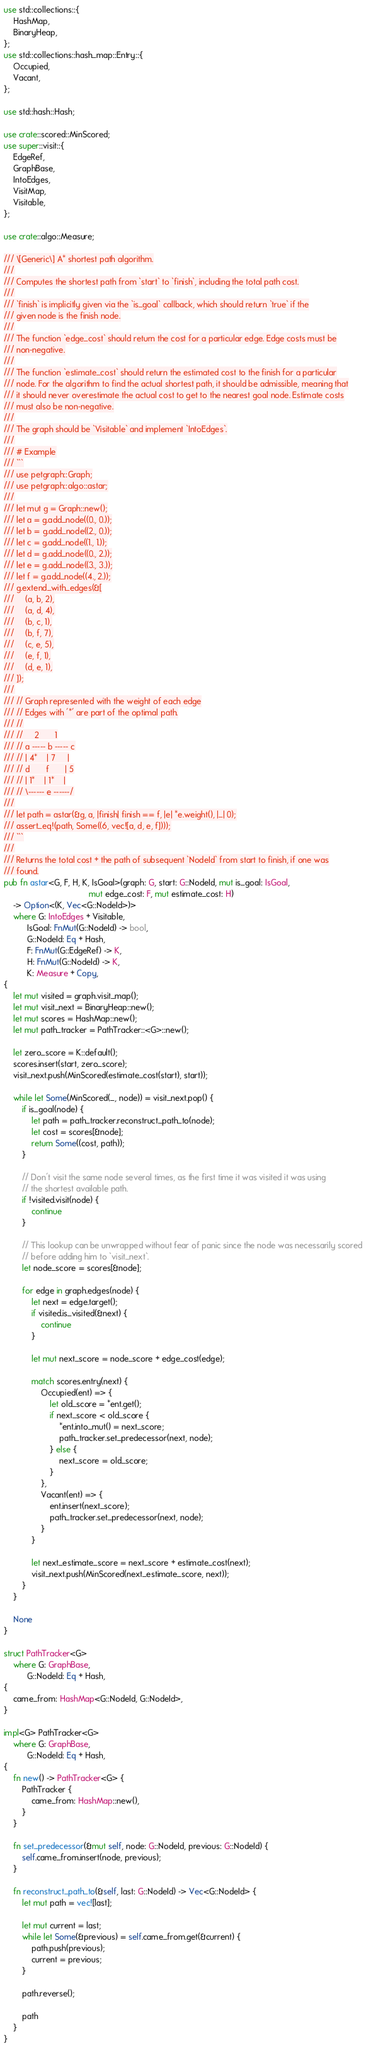<code> <loc_0><loc_0><loc_500><loc_500><_Rust_>use std::collections::{
    HashMap,
    BinaryHeap,
};
use std::collections::hash_map::Entry::{
    Occupied,
    Vacant,
};

use std::hash::Hash;

use crate::scored::MinScored;
use super::visit::{
    EdgeRef,
    GraphBase,
    IntoEdges,
    VisitMap,
    Visitable,
};

use crate::algo::Measure;

/// \[Generic\] A* shortest path algorithm.
///
/// Computes the shortest path from `start` to `finish`, including the total path cost.
///
/// `finish` is implicitly given via the `is_goal` callback, which should return `true` if the
/// given node is the finish node.
///
/// The function `edge_cost` should return the cost for a particular edge. Edge costs must be
/// non-negative.
///
/// The function `estimate_cost` should return the estimated cost to the finish for a particular
/// node. For the algorithm to find the actual shortest path, it should be admissible, meaning that
/// it should never overestimate the actual cost to get to the nearest goal node. Estimate costs
/// must also be non-negative.
///
/// The graph should be `Visitable` and implement `IntoEdges`.
///
/// # Example
/// ```
/// use petgraph::Graph;
/// use petgraph::algo::astar;
///
/// let mut g = Graph::new();
/// let a = g.add_node((0., 0.));
/// let b = g.add_node((2., 0.));
/// let c = g.add_node((1., 1.));
/// let d = g.add_node((0., 2.));
/// let e = g.add_node((3., 3.));
/// let f = g.add_node((4., 2.));
/// g.extend_with_edges(&[
///     (a, b, 2),
///     (a, d, 4),
///     (b, c, 1),
///     (b, f, 7),
///     (c, e, 5),
///     (e, f, 1),
///     (d, e, 1),
/// ]);
///
/// // Graph represented with the weight of each edge
/// // Edges with '*' are part of the optimal path.
/// //
/// //     2       1
/// // a ----- b ----- c
/// // | 4*    | 7     |
/// // d       f       | 5
/// // | 1*    | 1*    |
/// // \------ e ------/
///
/// let path = astar(&g, a, |finish| finish == f, |e| *e.weight(), |_| 0);
/// assert_eq!(path, Some((6, vec![a, d, e, f])));
/// ```
///
/// Returns the total cost + the path of subsequent `NodeId` from start to finish, if one was
/// found.
pub fn astar<G, F, H, K, IsGoal>(graph: G, start: G::NodeId, mut is_goal: IsGoal,
                                     mut edge_cost: F, mut estimate_cost: H)
    -> Option<(K, Vec<G::NodeId>)>
    where G: IntoEdges + Visitable,
          IsGoal: FnMut(G::NodeId) -> bool,
          G::NodeId: Eq + Hash,
          F: FnMut(G::EdgeRef) -> K,
          H: FnMut(G::NodeId) -> K,
          K: Measure + Copy,
{
    let mut visited = graph.visit_map();
    let mut visit_next = BinaryHeap::new();
    let mut scores = HashMap::new();
    let mut path_tracker = PathTracker::<G>::new();

    let zero_score = K::default();
    scores.insert(start, zero_score);
    visit_next.push(MinScored(estimate_cost(start), start));

    while let Some(MinScored(_, node)) = visit_next.pop() {
        if is_goal(node) {
            let path = path_tracker.reconstruct_path_to(node);
            let cost = scores[&node];
            return Some((cost, path));
        }

        // Don't visit the same node several times, as the first time it was visited it was using
        // the shortest available path.
        if !visited.visit(node) {
            continue
        }

        // This lookup can be unwrapped without fear of panic since the node was necessarily scored
        // before adding him to `visit_next`.
        let node_score = scores[&node];

        for edge in graph.edges(node) {
            let next = edge.target();
            if visited.is_visited(&next) {
                continue
            }

            let mut next_score = node_score + edge_cost(edge);

            match scores.entry(next) {
                Occupied(ent) => {
                    let old_score = *ent.get();
                    if next_score < old_score {
                        *ent.into_mut() = next_score;
                        path_tracker.set_predecessor(next, node);
                    } else {
                        next_score = old_score;
                    }
                },
                Vacant(ent) => {
                    ent.insert(next_score);
                    path_tracker.set_predecessor(next, node);
                }
            }

            let next_estimate_score = next_score + estimate_cost(next);
            visit_next.push(MinScored(next_estimate_score, next));
        }
    }

    None
}

struct PathTracker<G>
    where G: GraphBase,
          G::NodeId: Eq + Hash,
{
    came_from: HashMap<G::NodeId, G::NodeId>,
}

impl<G> PathTracker<G>
    where G: GraphBase,
          G::NodeId: Eq + Hash,
{
    fn new() -> PathTracker<G> {
        PathTracker {
            came_from: HashMap::new(),
        }
    }

    fn set_predecessor(&mut self, node: G::NodeId, previous: G::NodeId) {
        self.came_from.insert(node, previous);
    }

    fn reconstruct_path_to(&self, last: G::NodeId) -> Vec<G::NodeId> {
        let mut path = vec![last];

        let mut current = last;
        while let Some(&previous) = self.came_from.get(&current) {
            path.push(previous);
            current = previous;
        }

        path.reverse();

        path
    }
}
</code> 